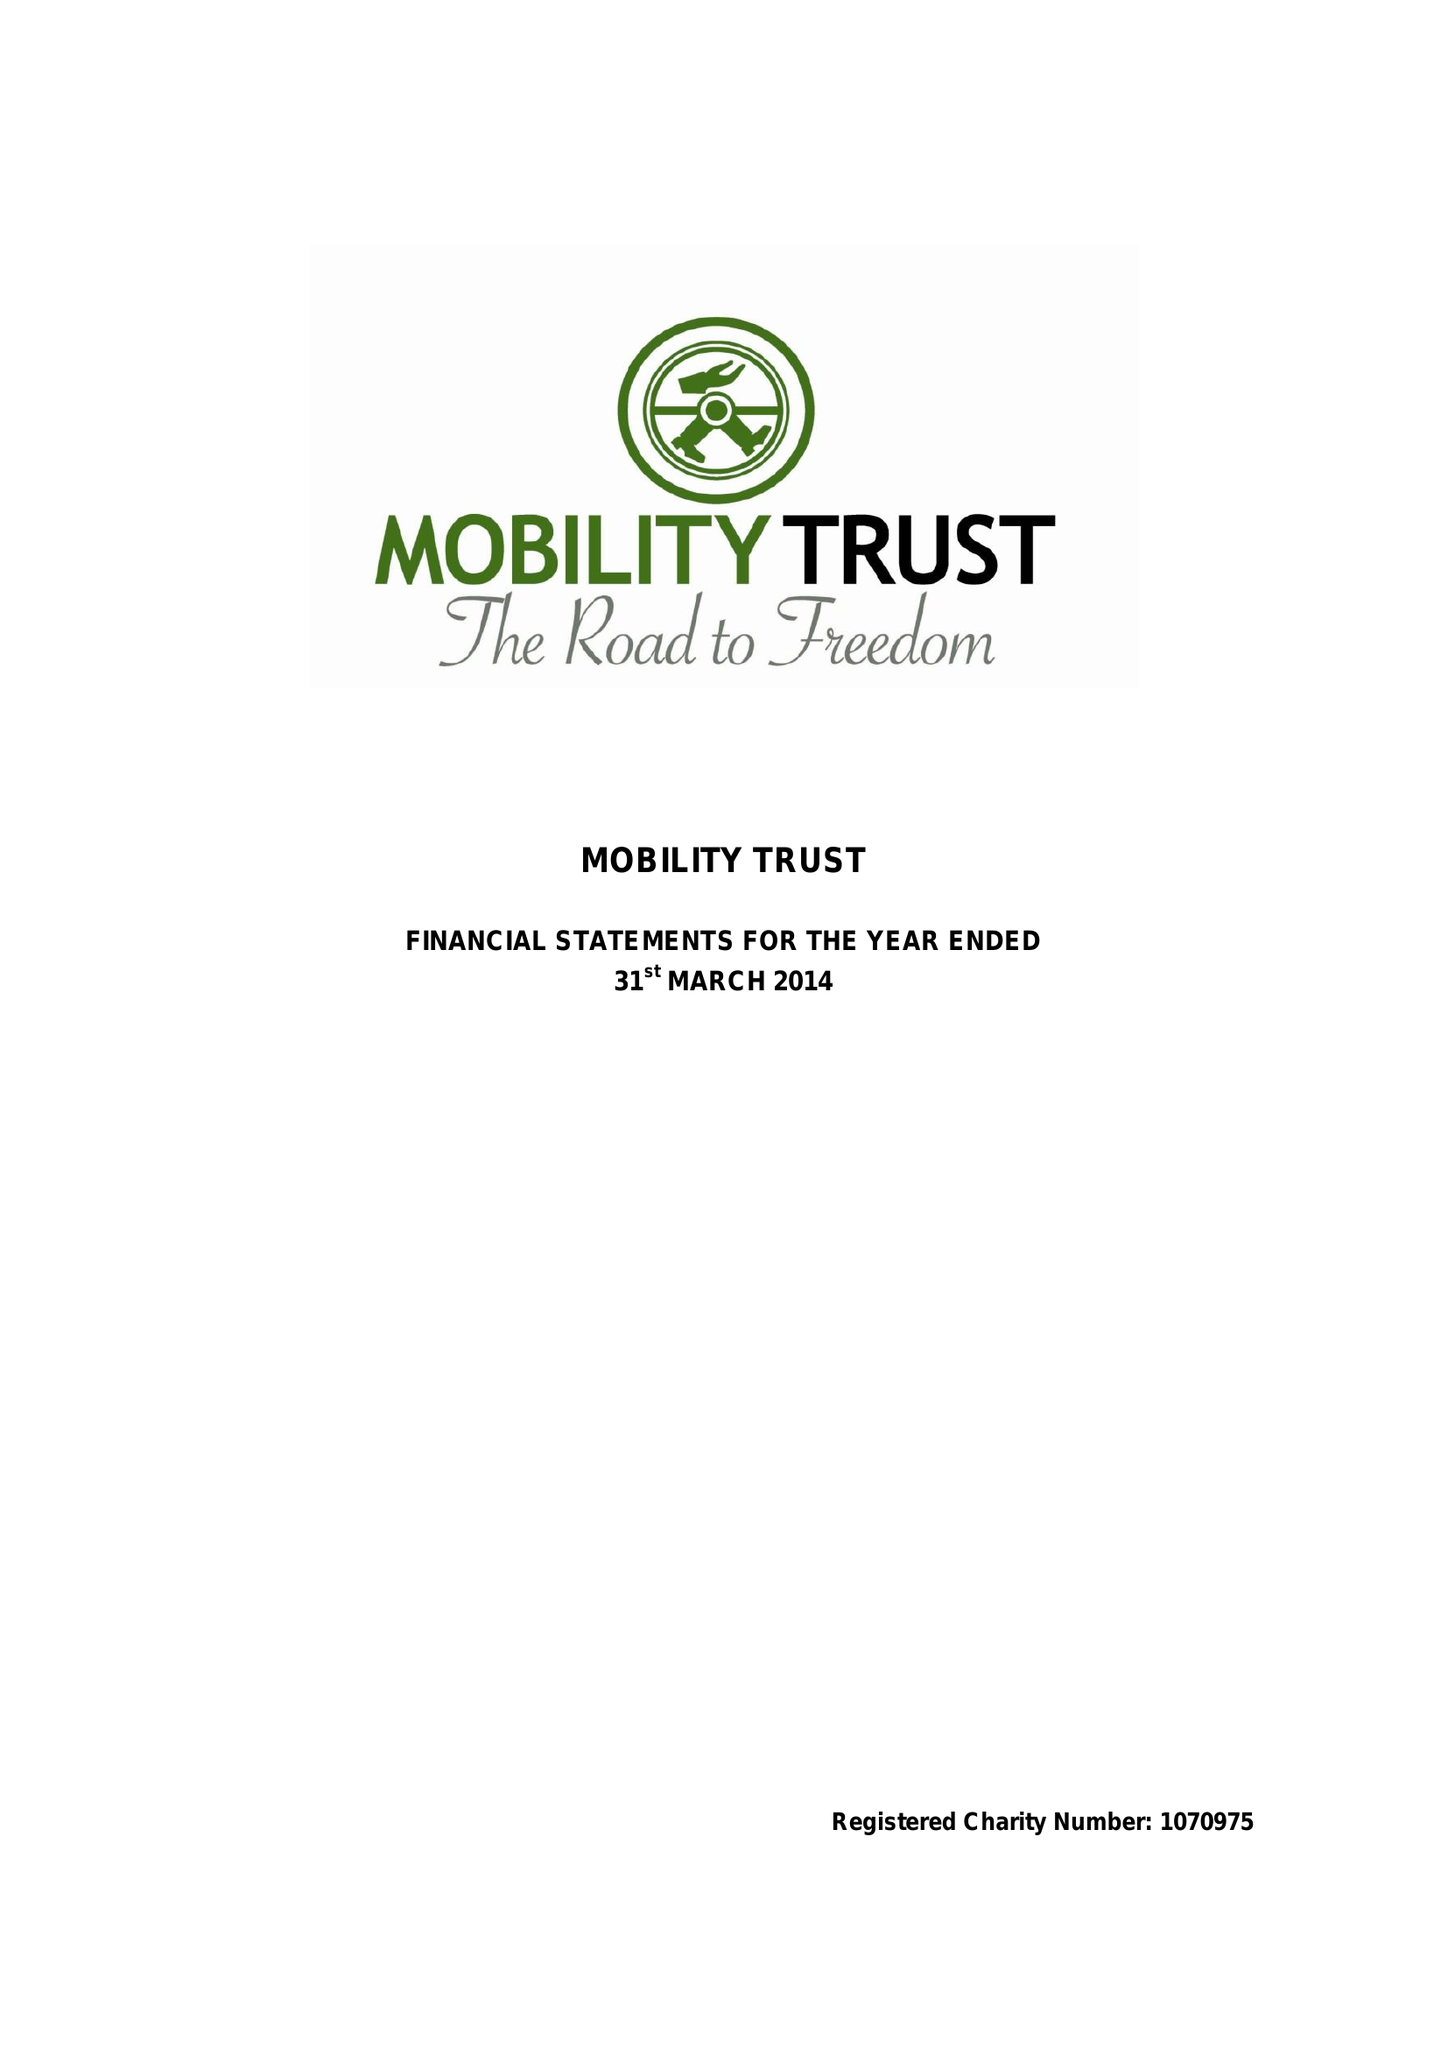What is the value for the spending_annually_in_british_pounds?
Answer the question using a single word or phrase. 292301.00 